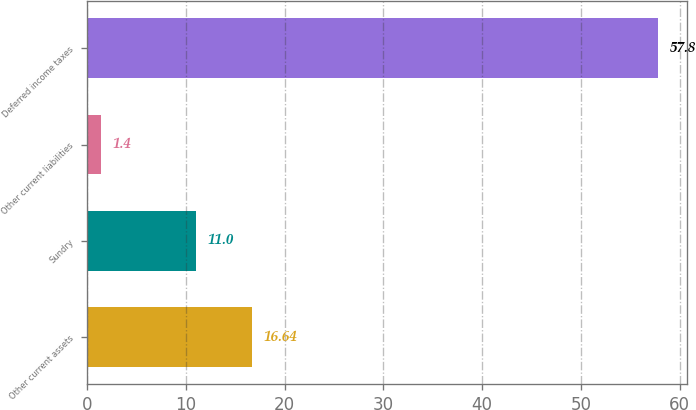Convert chart. <chart><loc_0><loc_0><loc_500><loc_500><bar_chart><fcel>Other current assets<fcel>Sundry<fcel>Other current liabilities<fcel>Deferred income taxes<nl><fcel>16.64<fcel>11<fcel>1.4<fcel>57.8<nl></chart> 